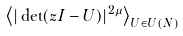<formula> <loc_0><loc_0><loc_500><loc_500>\left \langle | \det ( z I - U ) | ^ { 2 \mu } \right \rangle _ { U \in U ( N ) }</formula> 